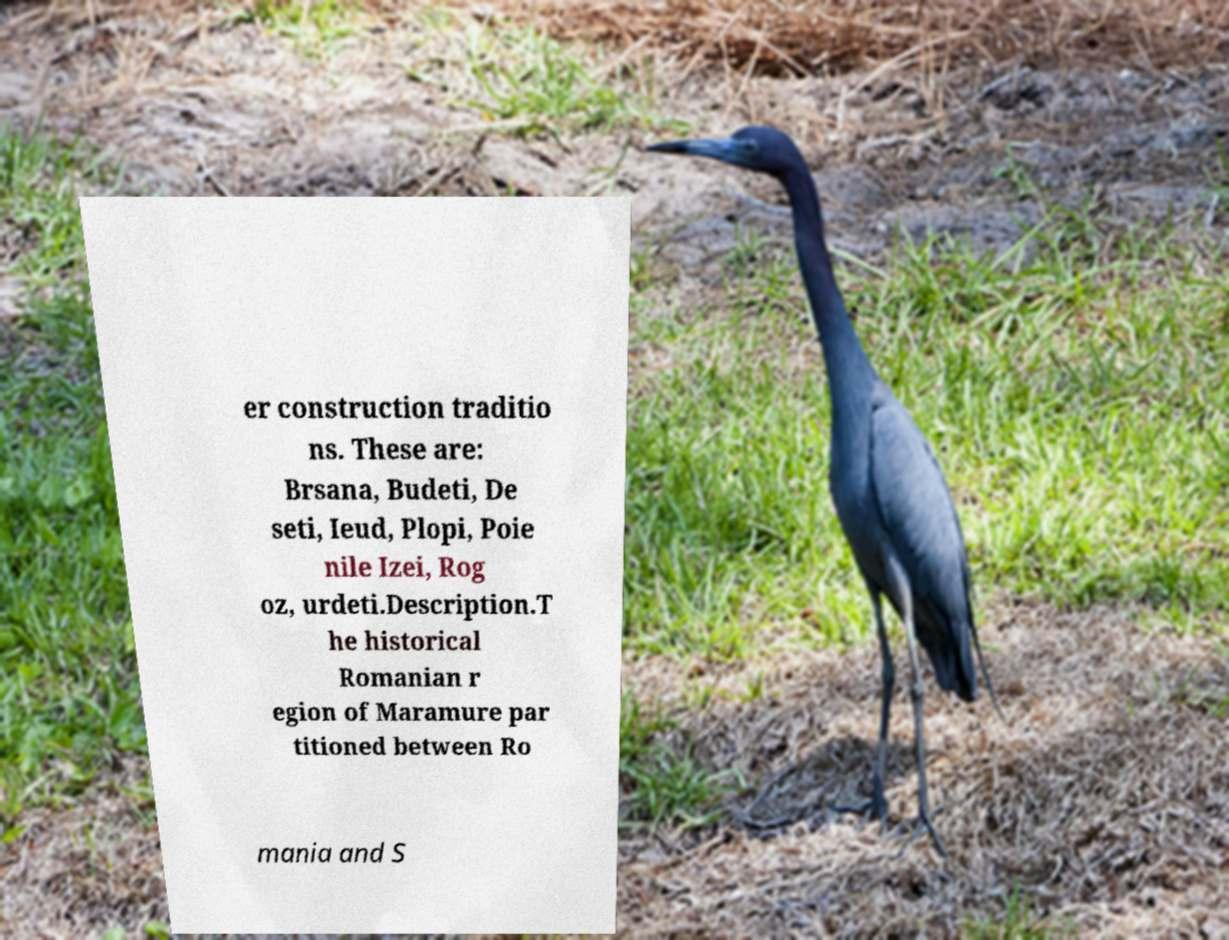Can you accurately transcribe the text from the provided image for me? er construction traditio ns. These are: Brsana, Budeti, De seti, Ieud, Plopi, Poie nile Izei, Rog oz, urdeti.Description.T he historical Romanian r egion of Maramure par titioned between Ro mania and S 